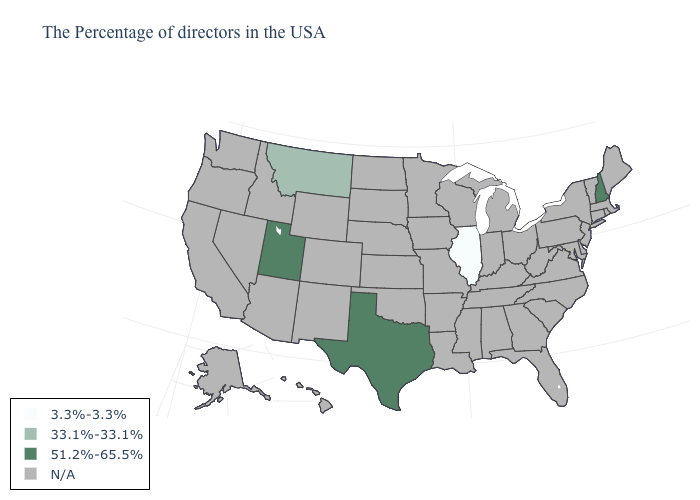Which states have the lowest value in the USA?
Answer briefly. Illinois. What is the value of Vermont?
Be succinct. N/A. What is the highest value in states that border New Mexico?
Give a very brief answer. 51.2%-65.5%. Does the map have missing data?
Give a very brief answer. Yes. What is the value of Kansas?
Keep it brief. N/A. Which states hav the highest value in the Northeast?
Give a very brief answer. New Hampshire. What is the highest value in the MidWest ?
Keep it brief. 3.3%-3.3%. What is the value of New York?
Quick response, please. N/A. Name the states that have a value in the range 3.3%-3.3%?
Quick response, please. Illinois. Which states have the highest value in the USA?
Concise answer only. New Hampshire, Texas, Utah. 